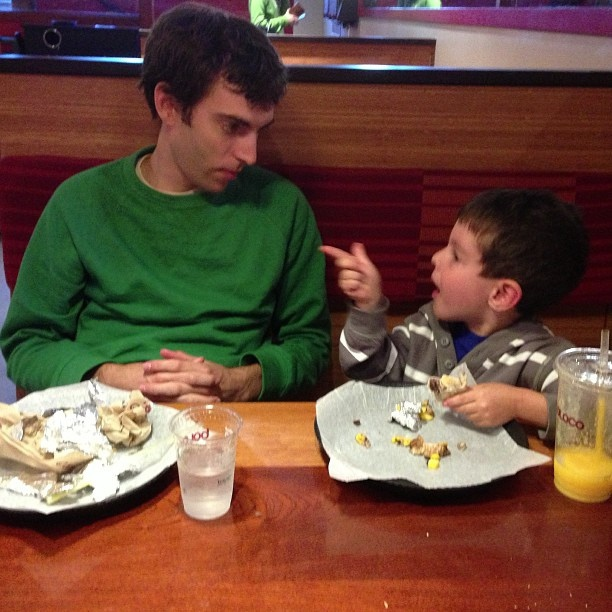Describe the objects in this image and their specific colors. I can see people in lightblue, darkgreen, black, brown, and maroon tones, dining table in lightblue, brown, maroon, and red tones, bench in lightblue, maroon, black, and brown tones, people in lightblue, black, brown, gray, and maroon tones, and cup in lightblue, tan, orange, gray, and darkgray tones in this image. 